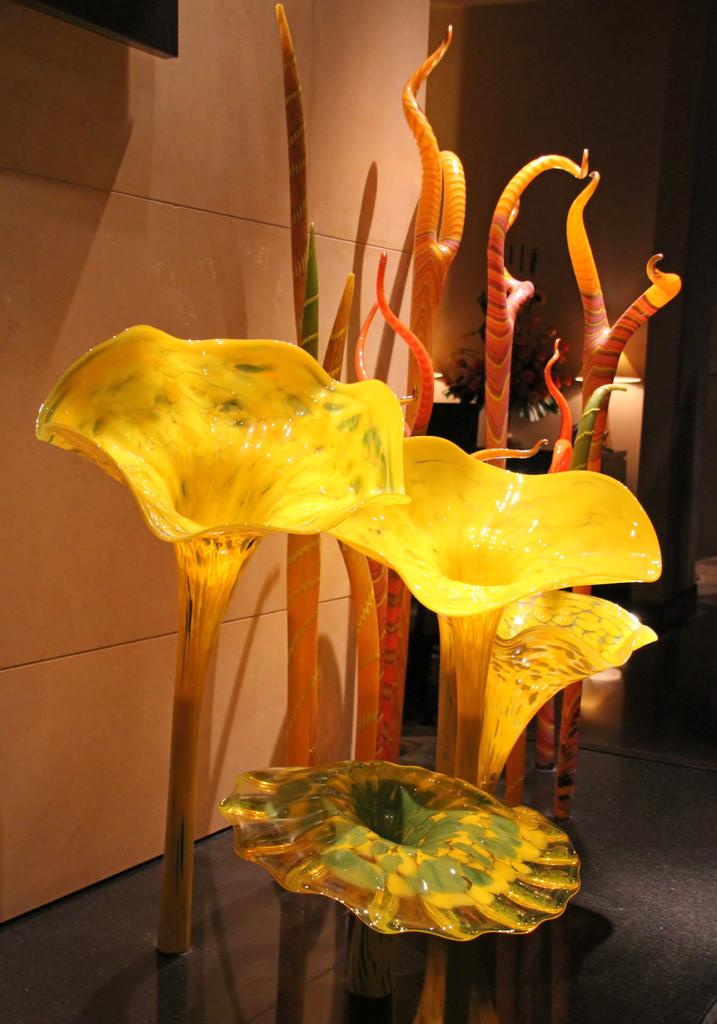What type of flowers are present in the image? There are artificial flowers in the image. What other objects can be seen in the image besides the flowers? There are other objects in the image, but their specific details are not mentioned in the facts. What can be seen in the background of the image? There is a house plant, a desk, and lamps in the background of the image. What type of jelly is being cooked in the oven in the image? There is no oven or jelly present in the image; it features artificial flowers and other objects. Can you describe the fly that is buzzing around the lamps in the image? There is no fly present in the image; it only features artificial flowers, other objects, a house plant, a desk, and lamps. 